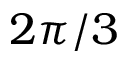Convert formula to latex. <formula><loc_0><loc_0><loc_500><loc_500>2 \pi / 3</formula> 